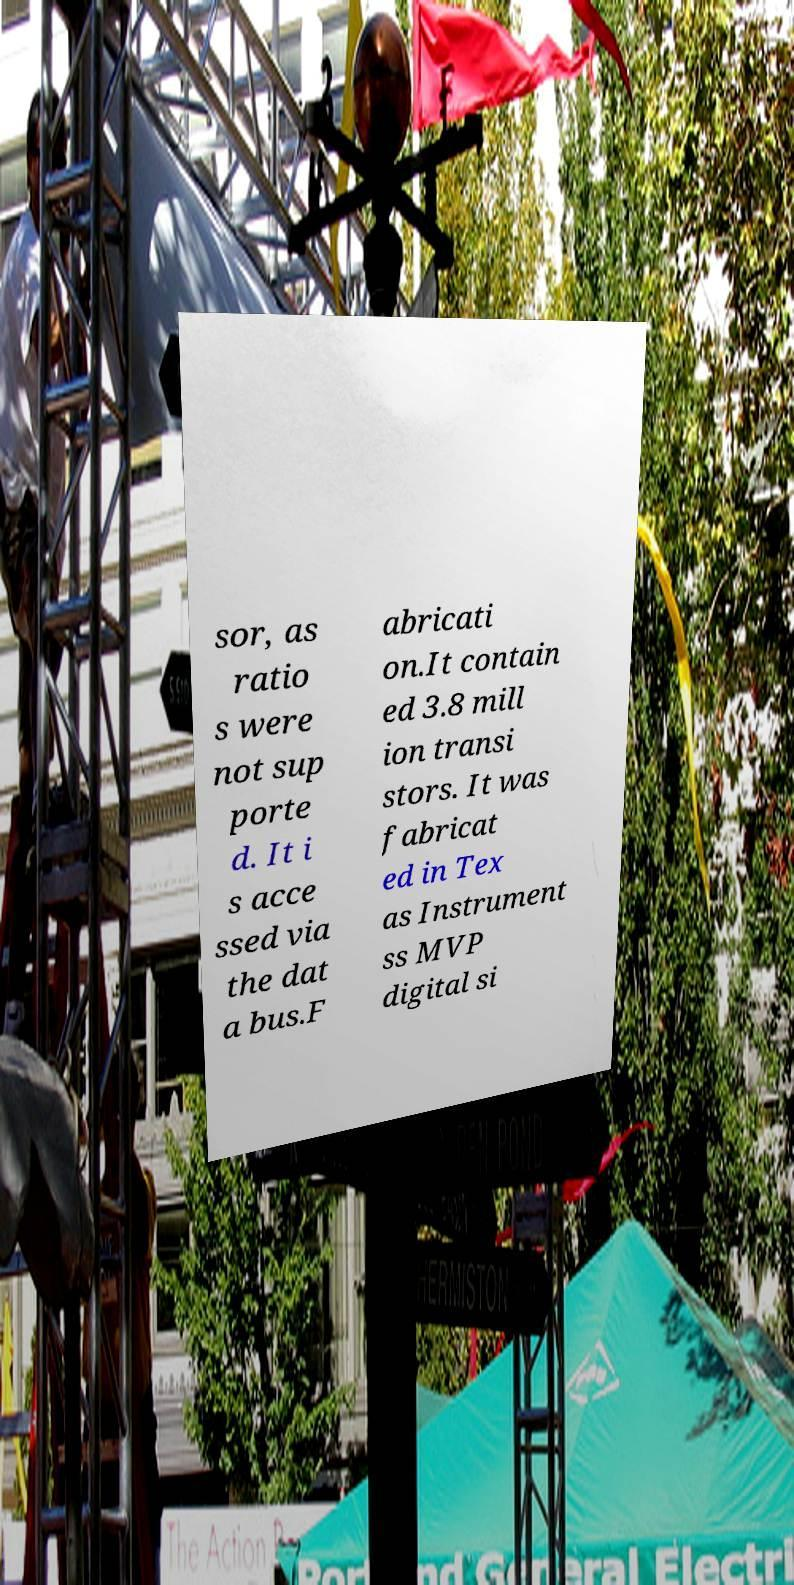Can you read and provide the text displayed in the image?This photo seems to have some interesting text. Can you extract and type it out for me? sor, as ratio s were not sup porte d. It i s acce ssed via the dat a bus.F abricati on.It contain ed 3.8 mill ion transi stors. It was fabricat ed in Tex as Instrument ss MVP digital si 